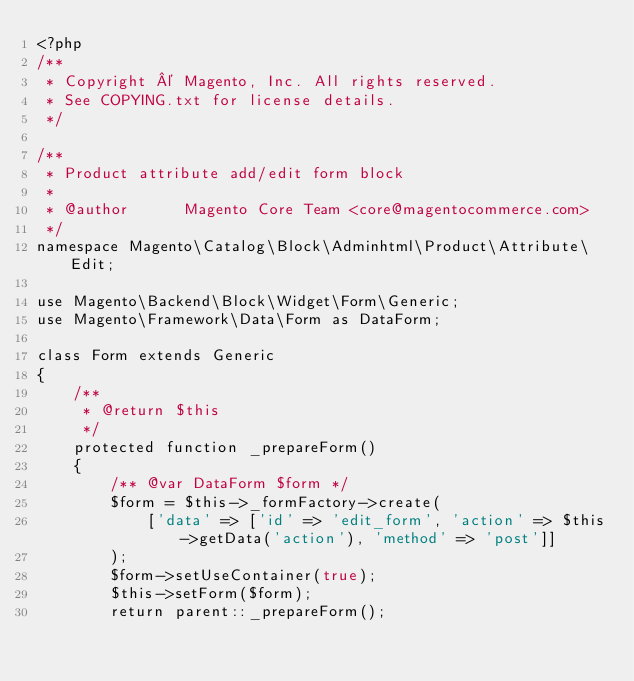Convert code to text. <code><loc_0><loc_0><loc_500><loc_500><_PHP_><?php
/**
 * Copyright © Magento, Inc. All rights reserved.
 * See COPYING.txt for license details.
 */

/**
 * Product attribute add/edit form block
 *
 * @author      Magento Core Team <core@magentocommerce.com>
 */
namespace Magento\Catalog\Block\Adminhtml\Product\Attribute\Edit;

use Magento\Backend\Block\Widget\Form\Generic;
use Magento\Framework\Data\Form as DataForm;

class Form extends Generic
{
    /**
     * @return $this
     */
    protected function _prepareForm()
    {
        /** @var DataForm $form */
        $form = $this->_formFactory->create(
            ['data' => ['id' => 'edit_form', 'action' => $this->getData('action'), 'method' => 'post']]
        );
        $form->setUseContainer(true);
        $this->setForm($form);
        return parent::_prepareForm();</code> 